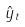Convert formula to latex. <formula><loc_0><loc_0><loc_500><loc_500>\hat { y } _ { t }</formula> 